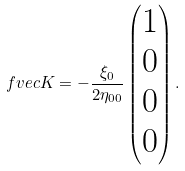Convert formula to latex. <formula><loc_0><loc_0><loc_500><loc_500>\ f v e c { K } = - \frac { \xi _ { 0 } } { 2 \eta _ { 0 0 } } \begin{pmatrix} 1 \\ 0 \\ 0 \\ 0 \end{pmatrix} .</formula> 